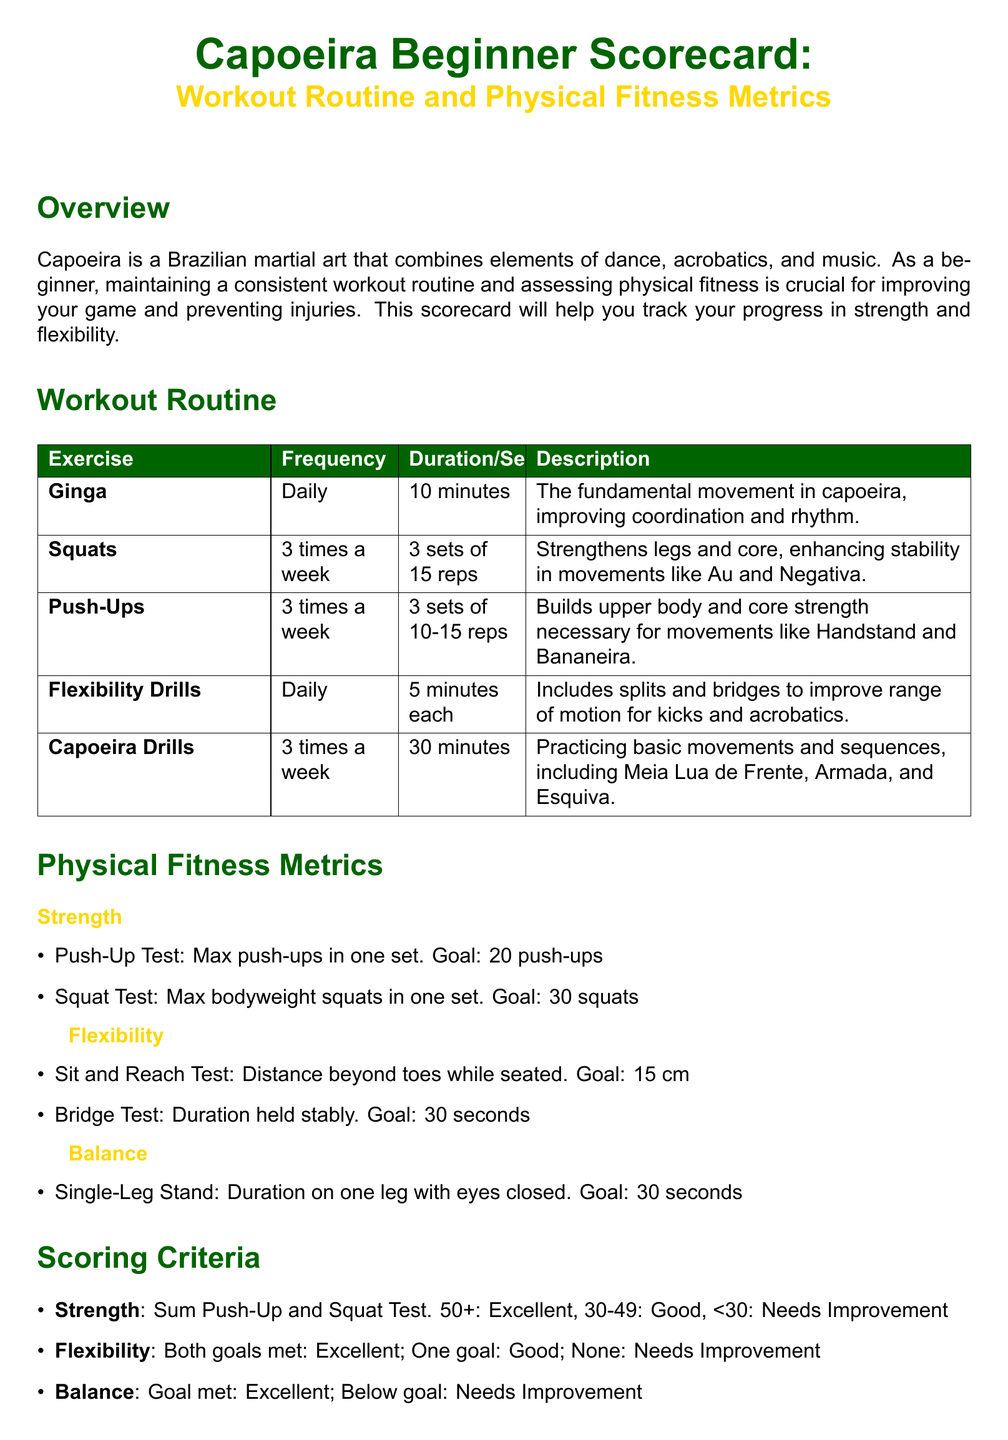What is the daily duration for Ginga? Ginga is practiced daily for 10 minutes according to the workout routine.
Answer: 10 minutes What are the goals for the Push-Up Test? The goal for the Push-Up Test is stated as a maximum number of push-ups achievable in one set.
Answer: 20 push-ups How many times a week are Squats performed? The workout routine specifies Squats are performed three times a week.
Answer: 3 times a week What is the flexibility goal for the Sit and Reach Test? The document lists the flexibility goal for the Sit and Reach Test as the distance beyond toes.
Answer: 15 cm What is the scoring criterion for excellent strength? The scoring for strength is defined based on the total max push-ups and squats.
Answer: 50+ What exercise focuses on balance? The document lists a specific test that assesses balance as a duration spent on one leg.
Answer: Single-Leg Stand How many sets and reps are recommended for Push-Ups? The amount of Push-Ups is specified in the workout routine in terms of sets and repetitions.
Answer: 3 sets of 10-15 reps How long should the Bridge Test be held stably for the flexibility goal? The document mentions a specific duration for the Bridge Test as part of the flexibility metrics.
Answer: 30 seconds What is the purpose of the Progress Tracker? The Progress Tracker is designed to monitor changes in specific physical fitness metrics over time.
Answer: To track progress 